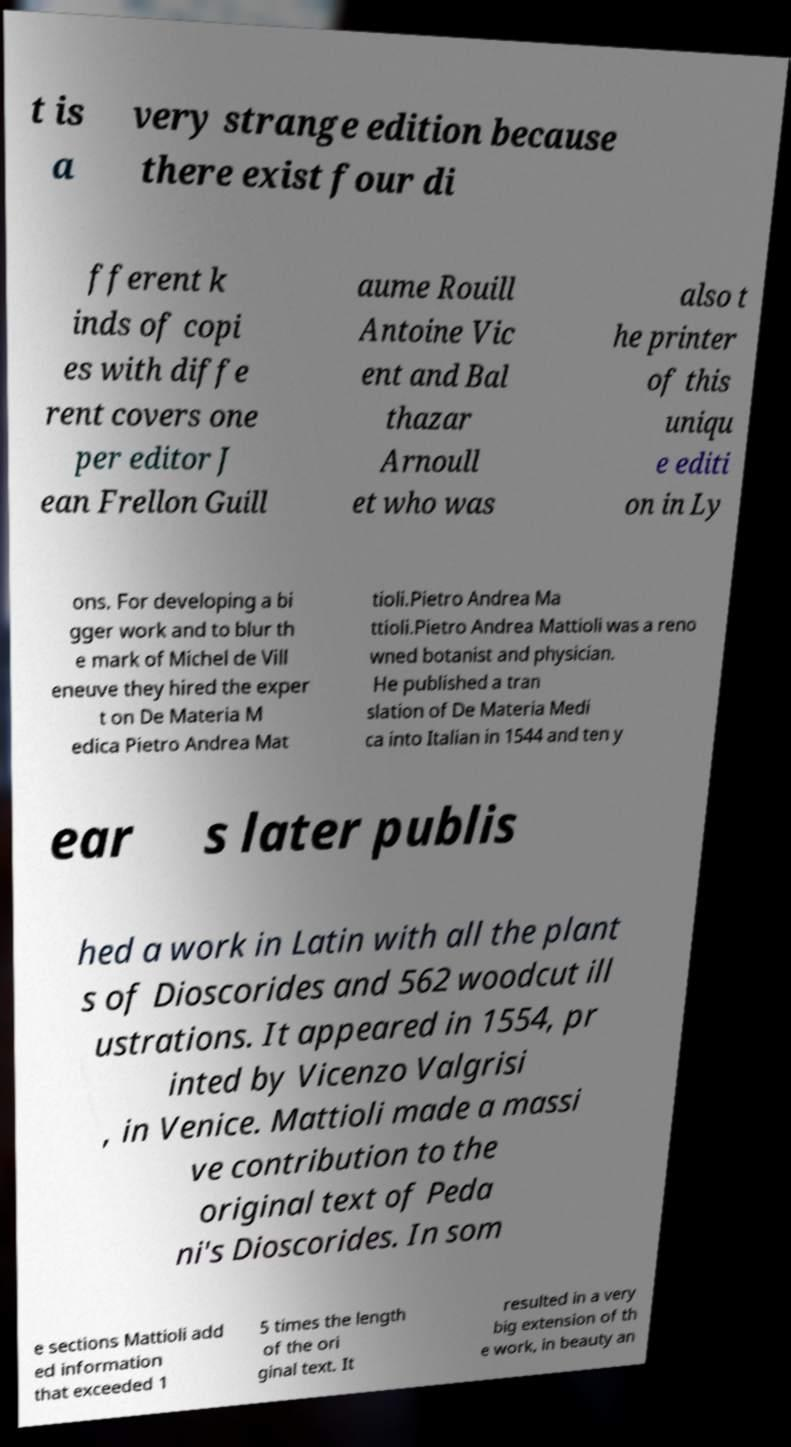What messages or text are displayed in this image? I need them in a readable, typed format. t is a very strange edition because there exist four di fferent k inds of copi es with diffe rent covers one per editor J ean Frellon Guill aume Rouill Antoine Vic ent and Bal thazar Arnoull et who was also t he printer of this uniqu e editi on in Ly ons. For developing a bi gger work and to blur th e mark of Michel de Vill eneuve they hired the exper t on De Materia M edica Pietro Andrea Mat tioli.Pietro Andrea Ma ttioli.Pietro Andrea Mattioli was a reno wned botanist and physician. He published a tran slation of De Materia Medi ca into Italian in 1544 and ten y ear s later publis hed a work in Latin with all the plant s of Dioscorides and 562 woodcut ill ustrations. It appeared in 1554, pr inted by Vicenzo Valgrisi , in Venice. Mattioli made a massi ve contribution to the original text of Peda ni's Dioscorides. In som e sections Mattioli add ed information that exceeded 1 5 times the length of the ori ginal text. It resulted in a very big extension of th e work, in beauty an 